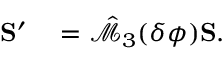<formula> <loc_0><loc_0><loc_500><loc_500>\begin{array} { r l } { { S } ^ { \prime } } & = \hat { \mathcal { M } } _ { 3 } ( \delta \phi ) { S } . } \end{array}</formula> 